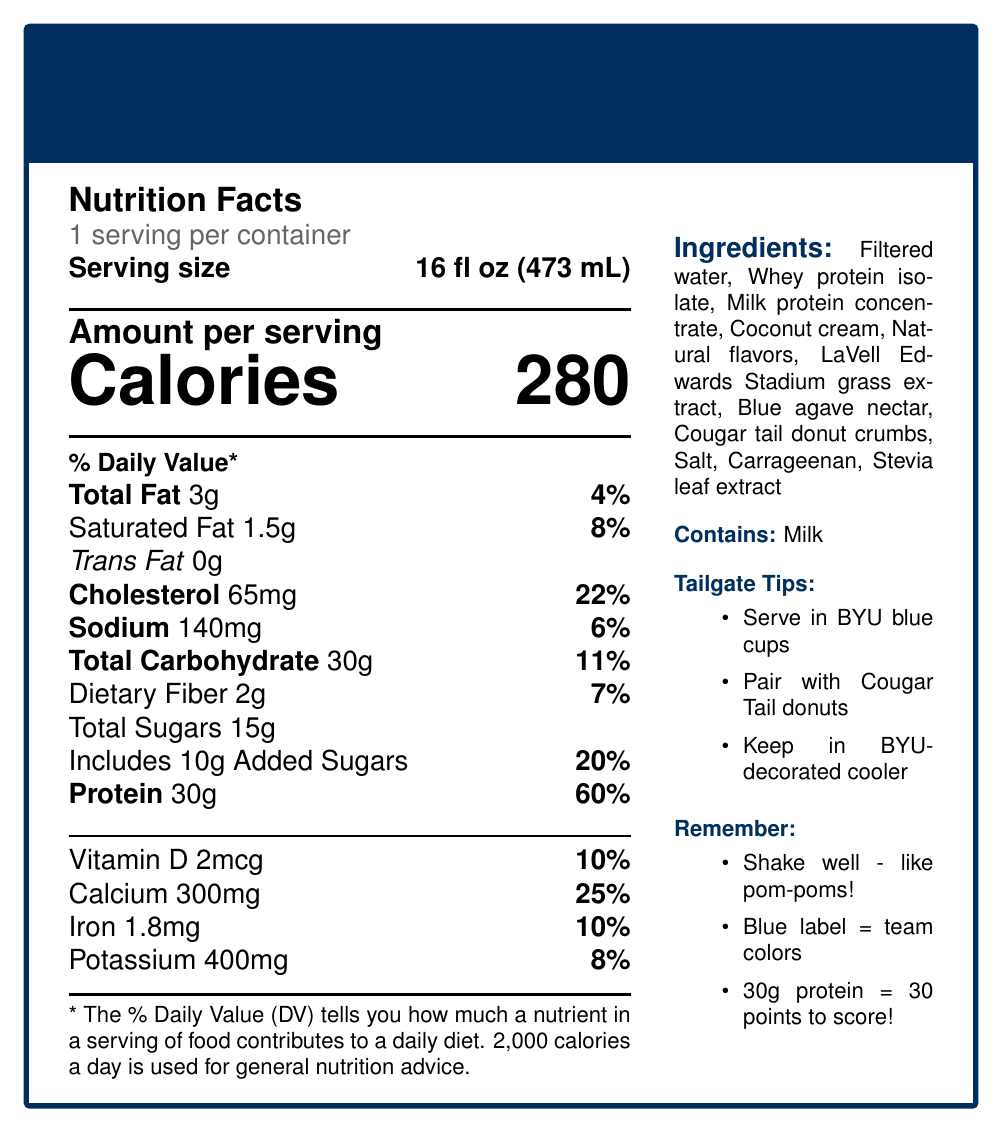what is the amount of protein per serving? The document states that the amount of protein per serving is 30g.
Answer: 30g what is the serving size of the BYU Cougars Game Day Power Shake? The serving size specified on the document is 16 fl oz (473 mL).
Answer: 16 fl oz (473 mL) how many calories are in one serving? The document clearly states that there are 280 calories per serving.
Answer: 280 what percentage of the daily value of calcium does one serving provide? The document indicates that one serving provides 25% of the daily value of calcium.
Answer: 25% list three of the ingredients in the BYU Cougars Game Day Power Shake The ingredients section lists Multiple ingredients. Three of these are Filtered water, Whey protein isolate, and Milk protein concentrate.
Answer: Filtered water, Whey protein isolate, Milk protein concentrate what type of fats are present in the shake? A. Saturated Fat B. Unsaturated Fat C. Trans Fat The document lists Saturated Fat (1.5g) and Trans Fat (0g), but only includes Saturated Fat as a present type.
Answer: A, C how should the shake be served to keep with the BYU theme? A. In red cups B. In BYU blue cups C. In plain white cups One of the tailgate serving suggestions is to serve the shake in BYU blue cups.
Answer: B which of the following contains added sugars in the shake? 1. Salt 2. Blue agave nectar 3. Stevia leaf extract 4. Cougar tail donut crumbs Blue agave nectar and Cougar tail donut crumbs are more likely to contain added sugars given their nature.
Answer: 2, 4 does the shake contain any allergens? The document mentions that the shake contains milk as an allergen.
Answer: Yes what should you remember about the protein amount in the shake? The document has a memory aid that links the 30g of protein to scoring 30 points in a game.
Answer: 30g of protein - one for each point we're gonna score today! what are the tailgate serving suggestions? These are listed under the tailgate serving suggestions section of the document.
Answer: The document lists serving suggestions like serving chilled in BYU blue cups, pairing with Cougar Tail donuts, keeping it in a BYU-decorated cooler, using it as a base for 'Cosmo's Courage Cocktail,' serving alongside 'Y Mountain Trail Mix,' and pouring over ice in a BYU souvenir shaker bottle. what’s the purpose of shaking well before drinking the shake? The memory aids section mentions shaking well before drinking, comparing it to shaking pom-poms at kickoff.
Answer: Just like shaking your pom-poms at kickoff! what is the total carbohydrate amount in one serving? The document lists the total carbohydrate amount per serving as 30g.
Answer: 30g does the information document provide nutritional details for multiple servings per container? The document specifies 1 serving per container.
Answer: No which is not an ingredient in the shake? A. Coconut cream B. Filtered water C. Artificial sweeteners D. Stevia leaf extract The ingredients list does not contain artificial sweeteners.
Answer: C describe the main idea of the document. The document features details regarding nutrition, ingredients, serving ideas, and easy-to-remember tips specifically tailored for BYU fans.
Answer: The document provides the nutrition facts, ingredients, allergens, tailgate serving suggestions, and memory aids for the BYU Cougars Game Day Power Shake, a protein shake themed around BYU Cougars sporting events. what is the exact amount of saturated fat in the shake? The document specifies that there is 1.5g of saturated fat in the shake.
Answer: 1.5g is there any caffeine content mentioned in the document? The document does not provide any details about caffeine content.
Answer: Not enough information 